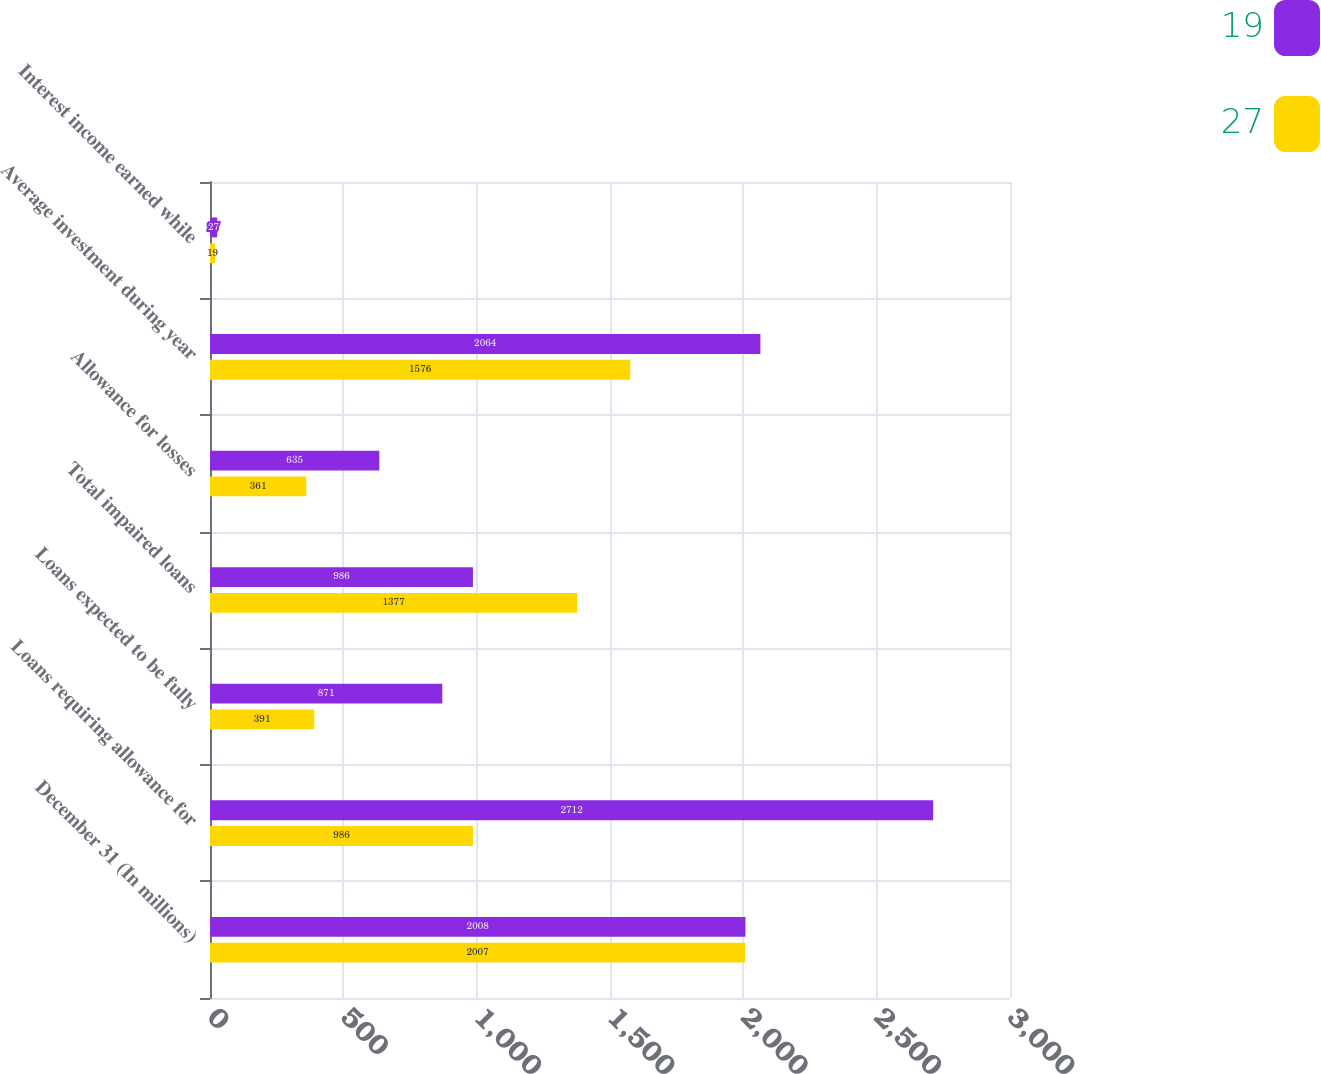<chart> <loc_0><loc_0><loc_500><loc_500><stacked_bar_chart><ecel><fcel>December 31 (In millions)<fcel>Loans requiring allowance for<fcel>Loans expected to be fully<fcel>Total impaired loans<fcel>Allowance for losses<fcel>Average investment during year<fcel>Interest income earned while<nl><fcel>19<fcel>2008<fcel>2712<fcel>871<fcel>986<fcel>635<fcel>2064<fcel>27<nl><fcel>27<fcel>2007<fcel>986<fcel>391<fcel>1377<fcel>361<fcel>1576<fcel>19<nl></chart> 